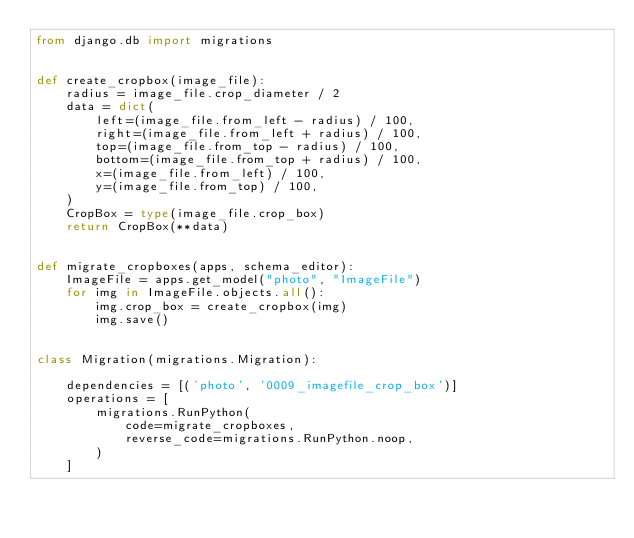<code> <loc_0><loc_0><loc_500><loc_500><_Python_>from django.db import migrations


def create_cropbox(image_file):
    radius = image_file.crop_diameter / 2
    data = dict(
        left=(image_file.from_left - radius) / 100,
        right=(image_file.from_left + radius) / 100,
        top=(image_file.from_top - radius) / 100,
        bottom=(image_file.from_top + radius) / 100,
        x=(image_file.from_left) / 100,
        y=(image_file.from_top) / 100,
    )
    CropBox = type(image_file.crop_box)
    return CropBox(**data)


def migrate_cropboxes(apps, schema_editor):
    ImageFile = apps.get_model("photo", "ImageFile")
    for img in ImageFile.objects.all():
        img.crop_box = create_cropbox(img)
        img.save()


class Migration(migrations.Migration):

    dependencies = [('photo', '0009_imagefile_crop_box')]
    operations = [
        migrations.RunPython(
            code=migrate_cropboxes,
            reverse_code=migrations.RunPython.noop,
        )
    ]
</code> 